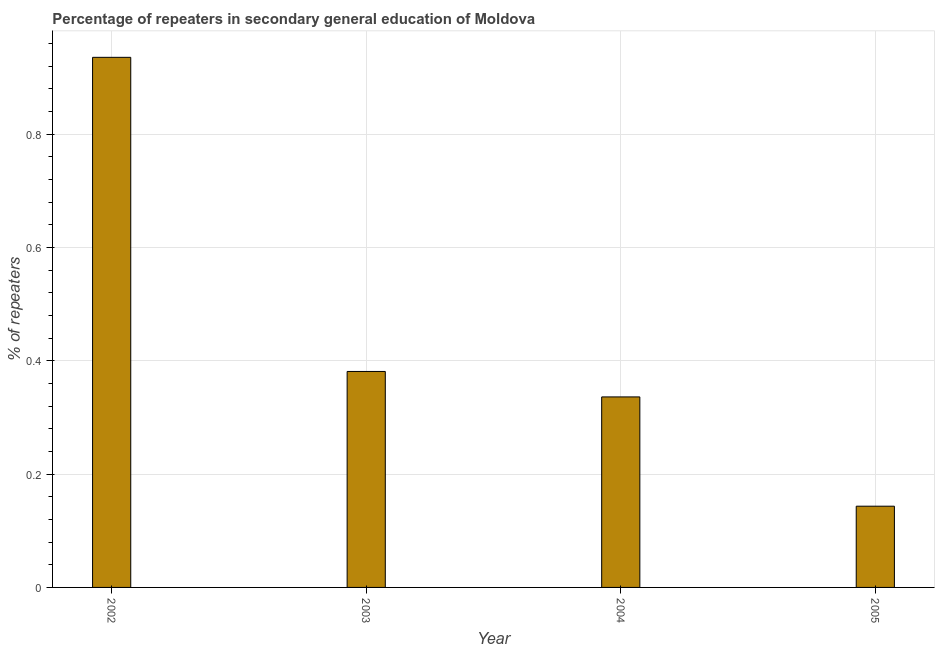Does the graph contain any zero values?
Offer a terse response. No. What is the title of the graph?
Make the answer very short. Percentage of repeaters in secondary general education of Moldova. What is the label or title of the Y-axis?
Offer a very short reply. % of repeaters. What is the percentage of repeaters in 2004?
Your response must be concise. 0.34. Across all years, what is the maximum percentage of repeaters?
Provide a succinct answer. 0.94. Across all years, what is the minimum percentage of repeaters?
Offer a terse response. 0.14. In which year was the percentage of repeaters minimum?
Ensure brevity in your answer.  2005. What is the sum of the percentage of repeaters?
Make the answer very short. 1.8. What is the difference between the percentage of repeaters in 2002 and 2005?
Your answer should be compact. 0.79. What is the average percentage of repeaters per year?
Ensure brevity in your answer.  0.45. What is the median percentage of repeaters?
Your response must be concise. 0.36. What is the ratio of the percentage of repeaters in 2003 to that in 2005?
Your response must be concise. 2.66. Is the percentage of repeaters in 2003 less than that in 2005?
Make the answer very short. No. Is the difference between the percentage of repeaters in 2002 and 2003 greater than the difference between any two years?
Provide a short and direct response. No. What is the difference between the highest and the second highest percentage of repeaters?
Ensure brevity in your answer.  0.56. Is the sum of the percentage of repeaters in 2004 and 2005 greater than the maximum percentage of repeaters across all years?
Offer a very short reply. No. What is the difference between the highest and the lowest percentage of repeaters?
Keep it short and to the point. 0.79. How many years are there in the graph?
Your answer should be very brief. 4. What is the difference between two consecutive major ticks on the Y-axis?
Give a very brief answer. 0.2. What is the % of repeaters in 2002?
Keep it short and to the point. 0.94. What is the % of repeaters of 2003?
Your answer should be compact. 0.38. What is the % of repeaters in 2004?
Your answer should be very brief. 0.34. What is the % of repeaters of 2005?
Provide a succinct answer. 0.14. What is the difference between the % of repeaters in 2002 and 2003?
Your answer should be very brief. 0.55. What is the difference between the % of repeaters in 2002 and 2004?
Ensure brevity in your answer.  0.6. What is the difference between the % of repeaters in 2002 and 2005?
Ensure brevity in your answer.  0.79. What is the difference between the % of repeaters in 2003 and 2004?
Keep it short and to the point. 0.04. What is the difference between the % of repeaters in 2003 and 2005?
Your response must be concise. 0.24. What is the difference between the % of repeaters in 2004 and 2005?
Give a very brief answer. 0.19. What is the ratio of the % of repeaters in 2002 to that in 2003?
Ensure brevity in your answer.  2.45. What is the ratio of the % of repeaters in 2002 to that in 2004?
Offer a terse response. 2.78. What is the ratio of the % of repeaters in 2002 to that in 2005?
Your answer should be compact. 6.53. What is the ratio of the % of repeaters in 2003 to that in 2004?
Your answer should be very brief. 1.13. What is the ratio of the % of repeaters in 2003 to that in 2005?
Give a very brief answer. 2.66. What is the ratio of the % of repeaters in 2004 to that in 2005?
Make the answer very short. 2.35. 